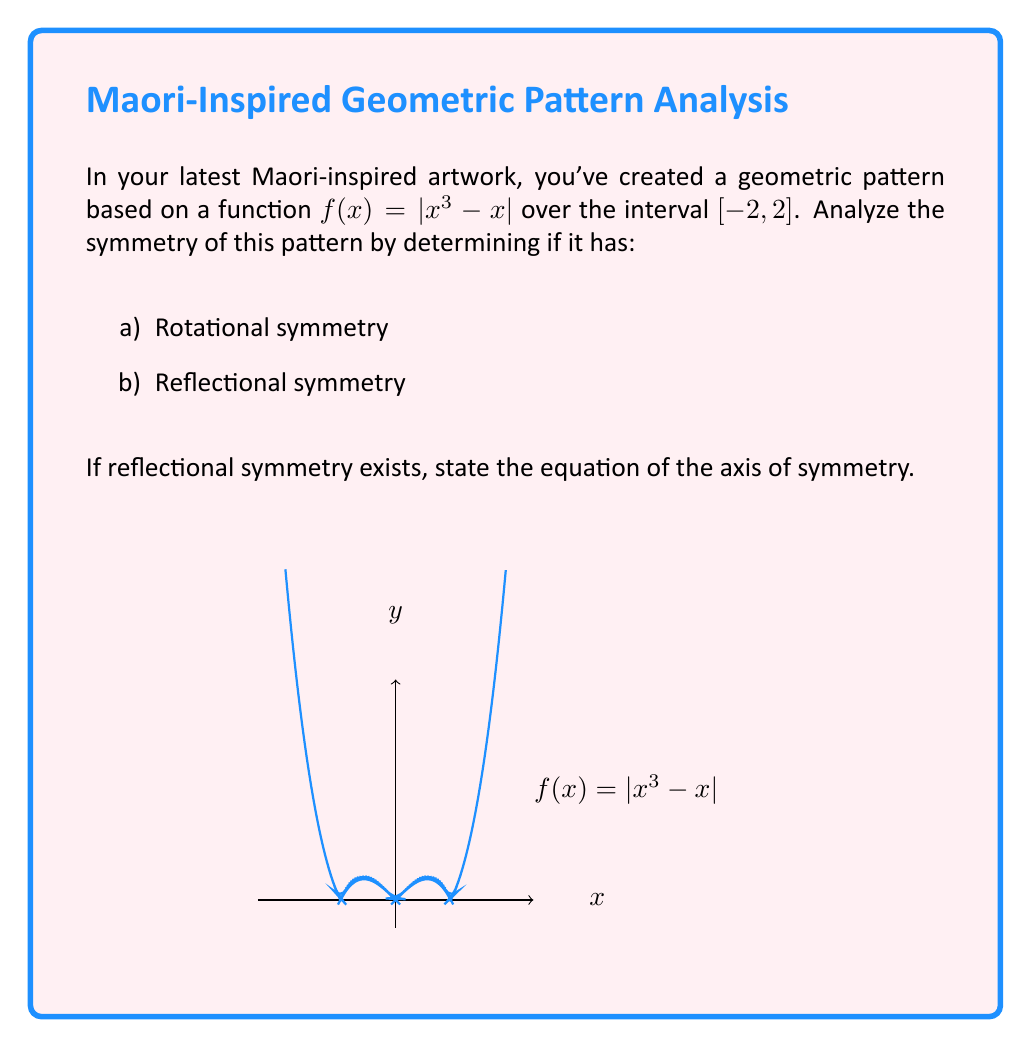Give your solution to this math problem. Let's analyze the symmetry of the function $f(x) = |x^3 - x|$ step by step:

1) First, let's check for reflectional symmetry:
   - A function has reflectional symmetry about the y-axis if $f(x) = f(-x)$ for all x in the domain.
   - Let's test this:
     $f(x) = |x^3 - x|$
     $f(-x) = |(-x)^3 - (-x)| = |-x^3 + x| = |x^3 - x| = f(x)$
   - Since $f(x) = f(-x)$, the function has reflectional symmetry about the y-axis.

2) The equation of the axis of symmetry is $x = 0$, which is the y-axis.

3) Now, let's check for rotational symmetry:
   - A function has 180° rotational symmetry if $f(x) = -f(-x)$ for all x in the domain.
   - Let's test this:
     $f(x) = |x^3 - x|$
     $-f(-x) = -|(-x)^3 - (-x)| = -|-x^3 + x| = -|x^3 - x| \neq f(x)$
   - Since $f(x) \neq -f(-x)$, the function does not have rotational symmetry.

4) Visual confirmation:
   - The graph is symmetric about the y-axis, confirming reflectional symmetry.
   - The graph is not symmetric under a 180° rotation about the origin, confirming the lack of rotational symmetry.
Answer: b) Reflectional symmetry about $x = 0$ 